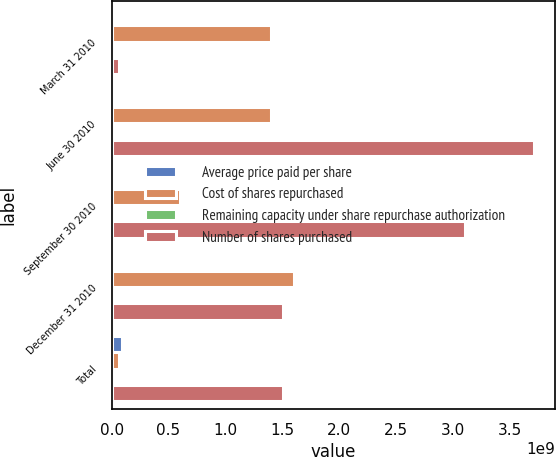<chart> <loc_0><loc_0><loc_500><loc_500><stacked_bar_chart><ecel><fcel>March 31 2010<fcel>June 30 2010<fcel>September 30 2010<fcel>December 31 2010<fcel>Total<nl><fcel>Average price paid per share<fcel>2.69853e+07<fcel>2.79619e+07<fcel>1.18287e+07<fcel>2.89483e+07<fcel>9.57243e+07<nl><fcel>Cost of shares repurchased<fcel>1.40005e+09<fcel>1.40017e+09<fcel>6.00057e+08<fcel>1.60003e+09<fcel>6.23363e+07<nl><fcel>Remaining capacity under share repurchase authorization<fcel>51.88<fcel>50.07<fcel>50.73<fcel>55.27<fcel>52.24<nl><fcel>Number of shares purchased<fcel>6.23363e+07<fcel>3.70948e+09<fcel>3.10942e+09<fcel>1.50939e+09<fcel>1.50939e+09<nl></chart> 